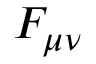<formula> <loc_0><loc_0><loc_500><loc_500>F _ { \mu \nu }</formula> 